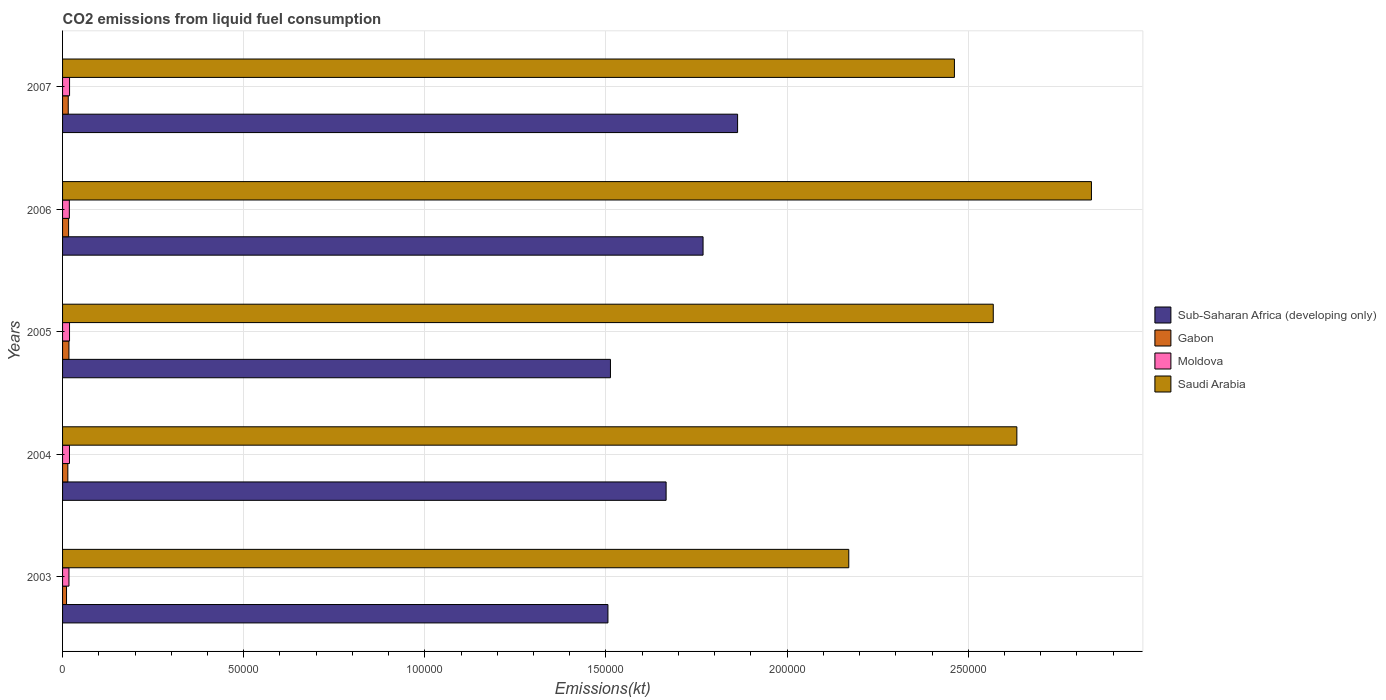How many different coloured bars are there?
Keep it short and to the point. 4. How many bars are there on the 4th tick from the top?
Your answer should be compact. 4. How many bars are there on the 3rd tick from the bottom?
Provide a short and direct response. 4. What is the amount of CO2 emitted in Saudi Arabia in 2004?
Offer a very short reply. 2.63e+05. Across all years, what is the maximum amount of CO2 emitted in Sub-Saharan Africa (developing only)?
Your response must be concise. 1.86e+05. Across all years, what is the minimum amount of CO2 emitted in Gabon?
Offer a very short reply. 1096.43. In which year was the amount of CO2 emitted in Moldova minimum?
Provide a short and direct response. 2003. What is the total amount of CO2 emitted in Sub-Saharan Africa (developing only) in the graph?
Give a very brief answer. 8.31e+05. What is the difference between the amount of CO2 emitted in Gabon in 2003 and that in 2006?
Give a very brief answer. -572.05. What is the difference between the amount of CO2 emitted in Saudi Arabia in 2004 and the amount of CO2 emitted in Moldova in 2005?
Ensure brevity in your answer.  2.61e+05. What is the average amount of CO2 emitted in Sub-Saharan Africa (developing only) per year?
Give a very brief answer. 1.66e+05. In the year 2004, what is the difference between the amount of CO2 emitted in Gabon and amount of CO2 emitted in Sub-Saharan Africa (developing only)?
Make the answer very short. -1.65e+05. In how many years, is the amount of CO2 emitted in Sub-Saharan Africa (developing only) greater than 100000 kt?
Make the answer very short. 5. What is the ratio of the amount of CO2 emitted in Sub-Saharan Africa (developing only) in 2003 to that in 2006?
Keep it short and to the point. 0.85. What is the difference between the highest and the second highest amount of CO2 emitted in Saudi Arabia?
Make the answer very short. 2.06e+04. What is the difference between the highest and the lowest amount of CO2 emitted in Sub-Saharan Africa (developing only)?
Provide a short and direct response. 3.58e+04. In how many years, is the amount of CO2 emitted in Sub-Saharan Africa (developing only) greater than the average amount of CO2 emitted in Sub-Saharan Africa (developing only) taken over all years?
Provide a succinct answer. 3. Is the sum of the amount of CO2 emitted in Gabon in 2003 and 2006 greater than the maximum amount of CO2 emitted in Saudi Arabia across all years?
Your answer should be compact. No. What does the 4th bar from the top in 2007 represents?
Make the answer very short. Sub-Saharan Africa (developing only). What does the 4th bar from the bottom in 2007 represents?
Your response must be concise. Saudi Arabia. Is it the case that in every year, the sum of the amount of CO2 emitted in Gabon and amount of CO2 emitted in Saudi Arabia is greater than the amount of CO2 emitted in Sub-Saharan Africa (developing only)?
Offer a very short reply. Yes. Are all the bars in the graph horizontal?
Offer a terse response. Yes. Does the graph contain any zero values?
Ensure brevity in your answer.  No. Does the graph contain grids?
Offer a terse response. Yes. How are the legend labels stacked?
Provide a succinct answer. Vertical. What is the title of the graph?
Provide a short and direct response. CO2 emissions from liquid fuel consumption. What is the label or title of the X-axis?
Ensure brevity in your answer.  Emissions(kt). What is the Emissions(kt) of Sub-Saharan Africa (developing only) in 2003?
Keep it short and to the point. 1.51e+05. What is the Emissions(kt) in Gabon in 2003?
Keep it short and to the point. 1096.43. What is the Emissions(kt) in Moldova in 2003?
Your answer should be very brief. 1767.49. What is the Emissions(kt) in Saudi Arabia in 2003?
Offer a terse response. 2.17e+05. What is the Emissions(kt) of Sub-Saharan Africa (developing only) in 2004?
Ensure brevity in your answer.  1.67e+05. What is the Emissions(kt) of Gabon in 2004?
Keep it short and to the point. 1455.8. What is the Emissions(kt) of Moldova in 2004?
Ensure brevity in your answer.  1910.51. What is the Emissions(kt) of Saudi Arabia in 2004?
Ensure brevity in your answer.  2.63e+05. What is the Emissions(kt) in Sub-Saharan Africa (developing only) in 2005?
Your answer should be very brief. 1.51e+05. What is the Emissions(kt) in Gabon in 2005?
Keep it short and to the point. 1763.83. What is the Emissions(kt) in Moldova in 2005?
Offer a terse response. 1921.51. What is the Emissions(kt) of Saudi Arabia in 2005?
Make the answer very short. 2.57e+05. What is the Emissions(kt) in Sub-Saharan Africa (developing only) in 2006?
Your response must be concise. 1.77e+05. What is the Emissions(kt) of Gabon in 2006?
Provide a succinct answer. 1668.48. What is the Emissions(kt) in Moldova in 2006?
Offer a very short reply. 1870.17. What is the Emissions(kt) of Saudi Arabia in 2006?
Your answer should be very brief. 2.84e+05. What is the Emissions(kt) in Sub-Saharan Africa (developing only) in 2007?
Ensure brevity in your answer.  1.86e+05. What is the Emissions(kt) of Gabon in 2007?
Give a very brief answer. 1569.48. What is the Emissions(kt) of Moldova in 2007?
Provide a succinct answer. 1932.51. What is the Emissions(kt) in Saudi Arabia in 2007?
Ensure brevity in your answer.  2.46e+05. Across all years, what is the maximum Emissions(kt) of Sub-Saharan Africa (developing only)?
Make the answer very short. 1.86e+05. Across all years, what is the maximum Emissions(kt) in Gabon?
Your answer should be compact. 1763.83. Across all years, what is the maximum Emissions(kt) in Moldova?
Your answer should be very brief. 1932.51. Across all years, what is the maximum Emissions(kt) in Saudi Arabia?
Provide a short and direct response. 2.84e+05. Across all years, what is the minimum Emissions(kt) in Sub-Saharan Africa (developing only)?
Offer a terse response. 1.51e+05. Across all years, what is the minimum Emissions(kt) of Gabon?
Ensure brevity in your answer.  1096.43. Across all years, what is the minimum Emissions(kt) in Moldova?
Offer a very short reply. 1767.49. Across all years, what is the minimum Emissions(kt) of Saudi Arabia?
Offer a very short reply. 2.17e+05. What is the total Emissions(kt) in Sub-Saharan Africa (developing only) in the graph?
Your response must be concise. 8.31e+05. What is the total Emissions(kt) in Gabon in the graph?
Your answer should be very brief. 7554.02. What is the total Emissions(kt) of Moldova in the graph?
Your answer should be very brief. 9402.19. What is the total Emissions(kt) of Saudi Arabia in the graph?
Your answer should be very brief. 1.27e+06. What is the difference between the Emissions(kt) in Sub-Saharan Africa (developing only) in 2003 and that in 2004?
Provide a short and direct response. -1.61e+04. What is the difference between the Emissions(kt) in Gabon in 2003 and that in 2004?
Offer a very short reply. -359.37. What is the difference between the Emissions(kt) of Moldova in 2003 and that in 2004?
Give a very brief answer. -143.01. What is the difference between the Emissions(kt) of Saudi Arabia in 2003 and that in 2004?
Keep it short and to the point. -4.64e+04. What is the difference between the Emissions(kt) of Sub-Saharan Africa (developing only) in 2003 and that in 2005?
Your response must be concise. -695.18. What is the difference between the Emissions(kt) in Gabon in 2003 and that in 2005?
Provide a succinct answer. -667.39. What is the difference between the Emissions(kt) in Moldova in 2003 and that in 2005?
Give a very brief answer. -154.01. What is the difference between the Emissions(kt) of Saudi Arabia in 2003 and that in 2005?
Make the answer very short. -3.99e+04. What is the difference between the Emissions(kt) of Sub-Saharan Africa (developing only) in 2003 and that in 2006?
Your answer should be very brief. -2.63e+04. What is the difference between the Emissions(kt) of Gabon in 2003 and that in 2006?
Give a very brief answer. -572.05. What is the difference between the Emissions(kt) of Moldova in 2003 and that in 2006?
Offer a terse response. -102.68. What is the difference between the Emissions(kt) of Saudi Arabia in 2003 and that in 2006?
Your response must be concise. -6.70e+04. What is the difference between the Emissions(kt) of Sub-Saharan Africa (developing only) in 2003 and that in 2007?
Offer a terse response. -3.58e+04. What is the difference between the Emissions(kt) in Gabon in 2003 and that in 2007?
Give a very brief answer. -473.04. What is the difference between the Emissions(kt) in Moldova in 2003 and that in 2007?
Keep it short and to the point. -165.01. What is the difference between the Emissions(kt) in Saudi Arabia in 2003 and that in 2007?
Your answer should be compact. -2.92e+04. What is the difference between the Emissions(kt) in Sub-Saharan Africa (developing only) in 2004 and that in 2005?
Ensure brevity in your answer.  1.54e+04. What is the difference between the Emissions(kt) of Gabon in 2004 and that in 2005?
Your answer should be very brief. -308.03. What is the difference between the Emissions(kt) in Moldova in 2004 and that in 2005?
Provide a succinct answer. -11. What is the difference between the Emissions(kt) in Saudi Arabia in 2004 and that in 2005?
Your answer should be very brief. 6512.59. What is the difference between the Emissions(kt) in Sub-Saharan Africa (developing only) in 2004 and that in 2006?
Your response must be concise. -1.02e+04. What is the difference between the Emissions(kt) of Gabon in 2004 and that in 2006?
Provide a short and direct response. -212.69. What is the difference between the Emissions(kt) of Moldova in 2004 and that in 2006?
Offer a very short reply. 40.34. What is the difference between the Emissions(kt) in Saudi Arabia in 2004 and that in 2006?
Your answer should be compact. -2.06e+04. What is the difference between the Emissions(kt) in Sub-Saharan Africa (developing only) in 2004 and that in 2007?
Your answer should be compact. -1.97e+04. What is the difference between the Emissions(kt) of Gabon in 2004 and that in 2007?
Offer a terse response. -113.68. What is the difference between the Emissions(kt) of Moldova in 2004 and that in 2007?
Provide a short and direct response. -22. What is the difference between the Emissions(kt) of Saudi Arabia in 2004 and that in 2007?
Offer a very short reply. 1.72e+04. What is the difference between the Emissions(kt) of Sub-Saharan Africa (developing only) in 2005 and that in 2006?
Ensure brevity in your answer.  -2.56e+04. What is the difference between the Emissions(kt) in Gabon in 2005 and that in 2006?
Make the answer very short. 95.34. What is the difference between the Emissions(kt) of Moldova in 2005 and that in 2006?
Provide a succinct answer. 51.34. What is the difference between the Emissions(kt) of Saudi Arabia in 2005 and that in 2006?
Give a very brief answer. -2.71e+04. What is the difference between the Emissions(kt) of Sub-Saharan Africa (developing only) in 2005 and that in 2007?
Provide a short and direct response. -3.51e+04. What is the difference between the Emissions(kt) of Gabon in 2005 and that in 2007?
Ensure brevity in your answer.  194.35. What is the difference between the Emissions(kt) in Moldova in 2005 and that in 2007?
Your answer should be compact. -11. What is the difference between the Emissions(kt) in Saudi Arabia in 2005 and that in 2007?
Your response must be concise. 1.07e+04. What is the difference between the Emissions(kt) in Sub-Saharan Africa (developing only) in 2006 and that in 2007?
Keep it short and to the point. -9530.23. What is the difference between the Emissions(kt) in Gabon in 2006 and that in 2007?
Ensure brevity in your answer.  99.01. What is the difference between the Emissions(kt) of Moldova in 2006 and that in 2007?
Give a very brief answer. -62.34. What is the difference between the Emissions(kt) of Saudi Arabia in 2006 and that in 2007?
Your response must be concise. 3.78e+04. What is the difference between the Emissions(kt) of Sub-Saharan Africa (developing only) in 2003 and the Emissions(kt) of Gabon in 2004?
Offer a very short reply. 1.49e+05. What is the difference between the Emissions(kt) of Sub-Saharan Africa (developing only) in 2003 and the Emissions(kt) of Moldova in 2004?
Your response must be concise. 1.49e+05. What is the difference between the Emissions(kt) in Sub-Saharan Africa (developing only) in 2003 and the Emissions(kt) in Saudi Arabia in 2004?
Give a very brief answer. -1.13e+05. What is the difference between the Emissions(kt) in Gabon in 2003 and the Emissions(kt) in Moldova in 2004?
Your response must be concise. -814.07. What is the difference between the Emissions(kt) in Gabon in 2003 and the Emissions(kt) in Saudi Arabia in 2004?
Offer a very short reply. -2.62e+05. What is the difference between the Emissions(kt) of Moldova in 2003 and the Emissions(kt) of Saudi Arabia in 2004?
Your answer should be very brief. -2.62e+05. What is the difference between the Emissions(kt) in Sub-Saharan Africa (developing only) in 2003 and the Emissions(kt) in Gabon in 2005?
Your answer should be very brief. 1.49e+05. What is the difference between the Emissions(kt) in Sub-Saharan Africa (developing only) in 2003 and the Emissions(kt) in Moldova in 2005?
Ensure brevity in your answer.  1.49e+05. What is the difference between the Emissions(kt) in Sub-Saharan Africa (developing only) in 2003 and the Emissions(kt) in Saudi Arabia in 2005?
Your response must be concise. -1.06e+05. What is the difference between the Emissions(kt) of Gabon in 2003 and the Emissions(kt) of Moldova in 2005?
Your answer should be compact. -825.08. What is the difference between the Emissions(kt) of Gabon in 2003 and the Emissions(kt) of Saudi Arabia in 2005?
Ensure brevity in your answer.  -2.56e+05. What is the difference between the Emissions(kt) of Moldova in 2003 and the Emissions(kt) of Saudi Arabia in 2005?
Provide a short and direct response. -2.55e+05. What is the difference between the Emissions(kt) of Sub-Saharan Africa (developing only) in 2003 and the Emissions(kt) of Gabon in 2006?
Keep it short and to the point. 1.49e+05. What is the difference between the Emissions(kt) of Sub-Saharan Africa (developing only) in 2003 and the Emissions(kt) of Moldova in 2006?
Ensure brevity in your answer.  1.49e+05. What is the difference between the Emissions(kt) of Sub-Saharan Africa (developing only) in 2003 and the Emissions(kt) of Saudi Arabia in 2006?
Provide a short and direct response. -1.33e+05. What is the difference between the Emissions(kt) in Gabon in 2003 and the Emissions(kt) in Moldova in 2006?
Provide a short and direct response. -773.74. What is the difference between the Emissions(kt) in Gabon in 2003 and the Emissions(kt) in Saudi Arabia in 2006?
Offer a very short reply. -2.83e+05. What is the difference between the Emissions(kt) of Moldova in 2003 and the Emissions(kt) of Saudi Arabia in 2006?
Provide a short and direct response. -2.82e+05. What is the difference between the Emissions(kt) of Sub-Saharan Africa (developing only) in 2003 and the Emissions(kt) of Gabon in 2007?
Provide a succinct answer. 1.49e+05. What is the difference between the Emissions(kt) of Sub-Saharan Africa (developing only) in 2003 and the Emissions(kt) of Moldova in 2007?
Offer a very short reply. 1.49e+05. What is the difference between the Emissions(kt) of Sub-Saharan Africa (developing only) in 2003 and the Emissions(kt) of Saudi Arabia in 2007?
Provide a succinct answer. -9.56e+04. What is the difference between the Emissions(kt) in Gabon in 2003 and the Emissions(kt) in Moldova in 2007?
Offer a very short reply. -836.08. What is the difference between the Emissions(kt) of Gabon in 2003 and the Emissions(kt) of Saudi Arabia in 2007?
Your response must be concise. -2.45e+05. What is the difference between the Emissions(kt) in Moldova in 2003 and the Emissions(kt) in Saudi Arabia in 2007?
Offer a terse response. -2.44e+05. What is the difference between the Emissions(kt) in Sub-Saharan Africa (developing only) in 2004 and the Emissions(kt) in Gabon in 2005?
Provide a short and direct response. 1.65e+05. What is the difference between the Emissions(kt) of Sub-Saharan Africa (developing only) in 2004 and the Emissions(kt) of Moldova in 2005?
Make the answer very short. 1.65e+05. What is the difference between the Emissions(kt) in Sub-Saharan Africa (developing only) in 2004 and the Emissions(kt) in Saudi Arabia in 2005?
Make the answer very short. -9.03e+04. What is the difference between the Emissions(kt) in Gabon in 2004 and the Emissions(kt) in Moldova in 2005?
Your answer should be compact. -465.71. What is the difference between the Emissions(kt) in Gabon in 2004 and the Emissions(kt) in Saudi Arabia in 2005?
Offer a very short reply. -2.55e+05. What is the difference between the Emissions(kt) of Moldova in 2004 and the Emissions(kt) of Saudi Arabia in 2005?
Your answer should be very brief. -2.55e+05. What is the difference between the Emissions(kt) of Sub-Saharan Africa (developing only) in 2004 and the Emissions(kt) of Gabon in 2006?
Ensure brevity in your answer.  1.65e+05. What is the difference between the Emissions(kt) in Sub-Saharan Africa (developing only) in 2004 and the Emissions(kt) in Moldova in 2006?
Make the answer very short. 1.65e+05. What is the difference between the Emissions(kt) in Sub-Saharan Africa (developing only) in 2004 and the Emissions(kt) in Saudi Arabia in 2006?
Offer a very short reply. -1.17e+05. What is the difference between the Emissions(kt) of Gabon in 2004 and the Emissions(kt) of Moldova in 2006?
Your answer should be very brief. -414.37. What is the difference between the Emissions(kt) in Gabon in 2004 and the Emissions(kt) in Saudi Arabia in 2006?
Provide a succinct answer. -2.83e+05. What is the difference between the Emissions(kt) of Moldova in 2004 and the Emissions(kt) of Saudi Arabia in 2006?
Provide a short and direct response. -2.82e+05. What is the difference between the Emissions(kt) in Sub-Saharan Africa (developing only) in 2004 and the Emissions(kt) in Gabon in 2007?
Your response must be concise. 1.65e+05. What is the difference between the Emissions(kt) in Sub-Saharan Africa (developing only) in 2004 and the Emissions(kt) in Moldova in 2007?
Provide a short and direct response. 1.65e+05. What is the difference between the Emissions(kt) of Sub-Saharan Africa (developing only) in 2004 and the Emissions(kt) of Saudi Arabia in 2007?
Your response must be concise. -7.96e+04. What is the difference between the Emissions(kt) of Gabon in 2004 and the Emissions(kt) of Moldova in 2007?
Your response must be concise. -476.71. What is the difference between the Emissions(kt) in Gabon in 2004 and the Emissions(kt) in Saudi Arabia in 2007?
Provide a succinct answer. -2.45e+05. What is the difference between the Emissions(kt) in Moldova in 2004 and the Emissions(kt) in Saudi Arabia in 2007?
Give a very brief answer. -2.44e+05. What is the difference between the Emissions(kt) in Sub-Saharan Africa (developing only) in 2005 and the Emissions(kt) in Gabon in 2006?
Offer a terse response. 1.50e+05. What is the difference between the Emissions(kt) of Sub-Saharan Africa (developing only) in 2005 and the Emissions(kt) of Moldova in 2006?
Your answer should be very brief. 1.49e+05. What is the difference between the Emissions(kt) of Sub-Saharan Africa (developing only) in 2005 and the Emissions(kt) of Saudi Arabia in 2006?
Your answer should be compact. -1.33e+05. What is the difference between the Emissions(kt) of Gabon in 2005 and the Emissions(kt) of Moldova in 2006?
Your answer should be compact. -106.34. What is the difference between the Emissions(kt) of Gabon in 2005 and the Emissions(kt) of Saudi Arabia in 2006?
Make the answer very short. -2.82e+05. What is the difference between the Emissions(kt) of Moldova in 2005 and the Emissions(kt) of Saudi Arabia in 2006?
Your answer should be compact. -2.82e+05. What is the difference between the Emissions(kt) in Sub-Saharan Africa (developing only) in 2005 and the Emissions(kt) in Gabon in 2007?
Give a very brief answer. 1.50e+05. What is the difference between the Emissions(kt) of Sub-Saharan Africa (developing only) in 2005 and the Emissions(kt) of Moldova in 2007?
Keep it short and to the point. 1.49e+05. What is the difference between the Emissions(kt) of Sub-Saharan Africa (developing only) in 2005 and the Emissions(kt) of Saudi Arabia in 2007?
Your answer should be very brief. -9.49e+04. What is the difference between the Emissions(kt) in Gabon in 2005 and the Emissions(kt) in Moldova in 2007?
Your answer should be very brief. -168.68. What is the difference between the Emissions(kt) of Gabon in 2005 and the Emissions(kt) of Saudi Arabia in 2007?
Ensure brevity in your answer.  -2.44e+05. What is the difference between the Emissions(kt) in Moldova in 2005 and the Emissions(kt) in Saudi Arabia in 2007?
Your answer should be compact. -2.44e+05. What is the difference between the Emissions(kt) in Sub-Saharan Africa (developing only) in 2006 and the Emissions(kt) in Gabon in 2007?
Offer a very short reply. 1.75e+05. What is the difference between the Emissions(kt) in Sub-Saharan Africa (developing only) in 2006 and the Emissions(kt) in Moldova in 2007?
Keep it short and to the point. 1.75e+05. What is the difference between the Emissions(kt) of Sub-Saharan Africa (developing only) in 2006 and the Emissions(kt) of Saudi Arabia in 2007?
Provide a succinct answer. -6.94e+04. What is the difference between the Emissions(kt) in Gabon in 2006 and the Emissions(kt) in Moldova in 2007?
Offer a very short reply. -264.02. What is the difference between the Emissions(kt) of Gabon in 2006 and the Emissions(kt) of Saudi Arabia in 2007?
Provide a succinct answer. -2.45e+05. What is the difference between the Emissions(kt) of Moldova in 2006 and the Emissions(kt) of Saudi Arabia in 2007?
Offer a terse response. -2.44e+05. What is the average Emissions(kt) of Sub-Saharan Africa (developing only) per year?
Give a very brief answer. 1.66e+05. What is the average Emissions(kt) of Gabon per year?
Provide a short and direct response. 1510.8. What is the average Emissions(kt) of Moldova per year?
Offer a terse response. 1880.44. What is the average Emissions(kt) in Saudi Arabia per year?
Your answer should be compact. 2.54e+05. In the year 2003, what is the difference between the Emissions(kt) in Sub-Saharan Africa (developing only) and Emissions(kt) in Gabon?
Offer a terse response. 1.49e+05. In the year 2003, what is the difference between the Emissions(kt) in Sub-Saharan Africa (developing only) and Emissions(kt) in Moldova?
Your response must be concise. 1.49e+05. In the year 2003, what is the difference between the Emissions(kt) in Sub-Saharan Africa (developing only) and Emissions(kt) in Saudi Arabia?
Make the answer very short. -6.65e+04. In the year 2003, what is the difference between the Emissions(kt) of Gabon and Emissions(kt) of Moldova?
Keep it short and to the point. -671.06. In the year 2003, what is the difference between the Emissions(kt) in Gabon and Emissions(kt) in Saudi Arabia?
Your response must be concise. -2.16e+05. In the year 2003, what is the difference between the Emissions(kt) in Moldova and Emissions(kt) in Saudi Arabia?
Your answer should be compact. -2.15e+05. In the year 2004, what is the difference between the Emissions(kt) of Sub-Saharan Africa (developing only) and Emissions(kt) of Gabon?
Give a very brief answer. 1.65e+05. In the year 2004, what is the difference between the Emissions(kt) of Sub-Saharan Africa (developing only) and Emissions(kt) of Moldova?
Your response must be concise. 1.65e+05. In the year 2004, what is the difference between the Emissions(kt) in Sub-Saharan Africa (developing only) and Emissions(kt) in Saudi Arabia?
Your answer should be compact. -9.68e+04. In the year 2004, what is the difference between the Emissions(kt) in Gabon and Emissions(kt) in Moldova?
Keep it short and to the point. -454.71. In the year 2004, what is the difference between the Emissions(kt) in Gabon and Emissions(kt) in Saudi Arabia?
Make the answer very short. -2.62e+05. In the year 2004, what is the difference between the Emissions(kt) in Moldova and Emissions(kt) in Saudi Arabia?
Your response must be concise. -2.62e+05. In the year 2005, what is the difference between the Emissions(kt) of Sub-Saharan Africa (developing only) and Emissions(kt) of Gabon?
Ensure brevity in your answer.  1.49e+05. In the year 2005, what is the difference between the Emissions(kt) in Sub-Saharan Africa (developing only) and Emissions(kt) in Moldova?
Your response must be concise. 1.49e+05. In the year 2005, what is the difference between the Emissions(kt) in Sub-Saharan Africa (developing only) and Emissions(kt) in Saudi Arabia?
Make the answer very short. -1.06e+05. In the year 2005, what is the difference between the Emissions(kt) of Gabon and Emissions(kt) of Moldova?
Give a very brief answer. -157.68. In the year 2005, what is the difference between the Emissions(kt) in Gabon and Emissions(kt) in Saudi Arabia?
Provide a short and direct response. -2.55e+05. In the year 2005, what is the difference between the Emissions(kt) in Moldova and Emissions(kt) in Saudi Arabia?
Give a very brief answer. -2.55e+05. In the year 2006, what is the difference between the Emissions(kt) of Sub-Saharan Africa (developing only) and Emissions(kt) of Gabon?
Your response must be concise. 1.75e+05. In the year 2006, what is the difference between the Emissions(kt) of Sub-Saharan Africa (developing only) and Emissions(kt) of Moldova?
Keep it short and to the point. 1.75e+05. In the year 2006, what is the difference between the Emissions(kt) in Sub-Saharan Africa (developing only) and Emissions(kt) in Saudi Arabia?
Make the answer very short. -1.07e+05. In the year 2006, what is the difference between the Emissions(kt) of Gabon and Emissions(kt) of Moldova?
Your response must be concise. -201.69. In the year 2006, what is the difference between the Emissions(kt) in Gabon and Emissions(kt) in Saudi Arabia?
Keep it short and to the point. -2.82e+05. In the year 2006, what is the difference between the Emissions(kt) of Moldova and Emissions(kt) of Saudi Arabia?
Keep it short and to the point. -2.82e+05. In the year 2007, what is the difference between the Emissions(kt) of Sub-Saharan Africa (developing only) and Emissions(kt) of Gabon?
Keep it short and to the point. 1.85e+05. In the year 2007, what is the difference between the Emissions(kt) in Sub-Saharan Africa (developing only) and Emissions(kt) in Moldova?
Make the answer very short. 1.84e+05. In the year 2007, what is the difference between the Emissions(kt) in Sub-Saharan Africa (developing only) and Emissions(kt) in Saudi Arabia?
Your answer should be compact. -5.98e+04. In the year 2007, what is the difference between the Emissions(kt) in Gabon and Emissions(kt) in Moldova?
Offer a very short reply. -363.03. In the year 2007, what is the difference between the Emissions(kt) of Gabon and Emissions(kt) of Saudi Arabia?
Offer a terse response. -2.45e+05. In the year 2007, what is the difference between the Emissions(kt) of Moldova and Emissions(kt) of Saudi Arabia?
Give a very brief answer. -2.44e+05. What is the ratio of the Emissions(kt) of Sub-Saharan Africa (developing only) in 2003 to that in 2004?
Give a very brief answer. 0.9. What is the ratio of the Emissions(kt) in Gabon in 2003 to that in 2004?
Make the answer very short. 0.75. What is the ratio of the Emissions(kt) in Moldova in 2003 to that in 2004?
Offer a terse response. 0.93. What is the ratio of the Emissions(kt) in Saudi Arabia in 2003 to that in 2004?
Your response must be concise. 0.82. What is the ratio of the Emissions(kt) in Gabon in 2003 to that in 2005?
Ensure brevity in your answer.  0.62. What is the ratio of the Emissions(kt) in Moldova in 2003 to that in 2005?
Keep it short and to the point. 0.92. What is the ratio of the Emissions(kt) in Saudi Arabia in 2003 to that in 2005?
Make the answer very short. 0.84. What is the ratio of the Emissions(kt) in Sub-Saharan Africa (developing only) in 2003 to that in 2006?
Provide a short and direct response. 0.85. What is the ratio of the Emissions(kt) of Gabon in 2003 to that in 2006?
Offer a very short reply. 0.66. What is the ratio of the Emissions(kt) of Moldova in 2003 to that in 2006?
Provide a short and direct response. 0.95. What is the ratio of the Emissions(kt) of Saudi Arabia in 2003 to that in 2006?
Provide a succinct answer. 0.76. What is the ratio of the Emissions(kt) of Sub-Saharan Africa (developing only) in 2003 to that in 2007?
Your response must be concise. 0.81. What is the ratio of the Emissions(kt) of Gabon in 2003 to that in 2007?
Ensure brevity in your answer.  0.7. What is the ratio of the Emissions(kt) of Moldova in 2003 to that in 2007?
Your response must be concise. 0.91. What is the ratio of the Emissions(kt) of Saudi Arabia in 2003 to that in 2007?
Provide a short and direct response. 0.88. What is the ratio of the Emissions(kt) in Sub-Saharan Africa (developing only) in 2004 to that in 2005?
Keep it short and to the point. 1.1. What is the ratio of the Emissions(kt) in Gabon in 2004 to that in 2005?
Make the answer very short. 0.83. What is the ratio of the Emissions(kt) in Moldova in 2004 to that in 2005?
Offer a very short reply. 0.99. What is the ratio of the Emissions(kt) in Saudi Arabia in 2004 to that in 2005?
Offer a terse response. 1.03. What is the ratio of the Emissions(kt) of Sub-Saharan Africa (developing only) in 2004 to that in 2006?
Your answer should be compact. 0.94. What is the ratio of the Emissions(kt) in Gabon in 2004 to that in 2006?
Your response must be concise. 0.87. What is the ratio of the Emissions(kt) in Moldova in 2004 to that in 2006?
Your response must be concise. 1.02. What is the ratio of the Emissions(kt) in Saudi Arabia in 2004 to that in 2006?
Provide a short and direct response. 0.93. What is the ratio of the Emissions(kt) in Sub-Saharan Africa (developing only) in 2004 to that in 2007?
Ensure brevity in your answer.  0.89. What is the ratio of the Emissions(kt) of Gabon in 2004 to that in 2007?
Your answer should be very brief. 0.93. What is the ratio of the Emissions(kt) of Moldova in 2004 to that in 2007?
Provide a short and direct response. 0.99. What is the ratio of the Emissions(kt) of Saudi Arabia in 2004 to that in 2007?
Provide a succinct answer. 1.07. What is the ratio of the Emissions(kt) of Sub-Saharan Africa (developing only) in 2005 to that in 2006?
Give a very brief answer. 0.86. What is the ratio of the Emissions(kt) of Gabon in 2005 to that in 2006?
Offer a terse response. 1.06. What is the ratio of the Emissions(kt) in Moldova in 2005 to that in 2006?
Make the answer very short. 1.03. What is the ratio of the Emissions(kt) in Saudi Arabia in 2005 to that in 2006?
Offer a terse response. 0.9. What is the ratio of the Emissions(kt) in Sub-Saharan Africa (developing only) in 2005 to that in 2007?
Ensure brevity in your answer.  0.81. What is the ratio of the Emissions(kt) of Gabon in 2005 to that in 2007?
Provide a short and direct response. 1.12. What is the ratio of the Emissions(kt) in Saudi Arabia in 2005 to that in 2007?
Make the answer very short. 1.04. What is the ratio of the Emissions(kt) in Sub-Saharan Africa (developing only) in 2006 to that in 2007?
Keep it short and to the point. 0.95. What is the ratio of the Emissions(kt) of Gabon in 2006 to that in 2007?
Make the answer very short. 1.06. What is the ratio of the Emissions(kt) of Moldova in 2006 to that in 2007?
Your response must be concise. 0.97. What is the ratio of the Emissions(kt) of Saudi Arabia in 2006 to that in 2007?
Offer a very short reply. 1.15. What is the difference between the highest and the second highest Emissions(kt) in Sub-Saharan Africa (developing only)?
Your answer should be very brief. 9530.23. What is the difference between the highest and the second highest Emissions(kt) of Gabon?
Your response must be concise. 95.34. What is the difference between the highest and the second highest Emissions(kt) of Moldova?
Give a very brief answer. 11. What is the difference between the highest and the second highest Emissions(kt) in Saudi Arabia?
Ensure brevity in your answer.  2.06e+04. What is the difference between the highest and the lowest Emissions(kt) in Sub-Saharan Africa (developing only)?
Provide a short and direct response. 3.58e+04. What is the difference between the highest and the lowest Emissions(kt) of Gabon?
Give a very brief answer. 667.39. What is the difference between the highest and the lowest Emissions(kt) in Moldova?
Your response must be concise. 165.01. What is the difference between the highest and the lowest Emissions(kt) of Saudi Arabia?
Offer a very short reply. 6.70e+04. 